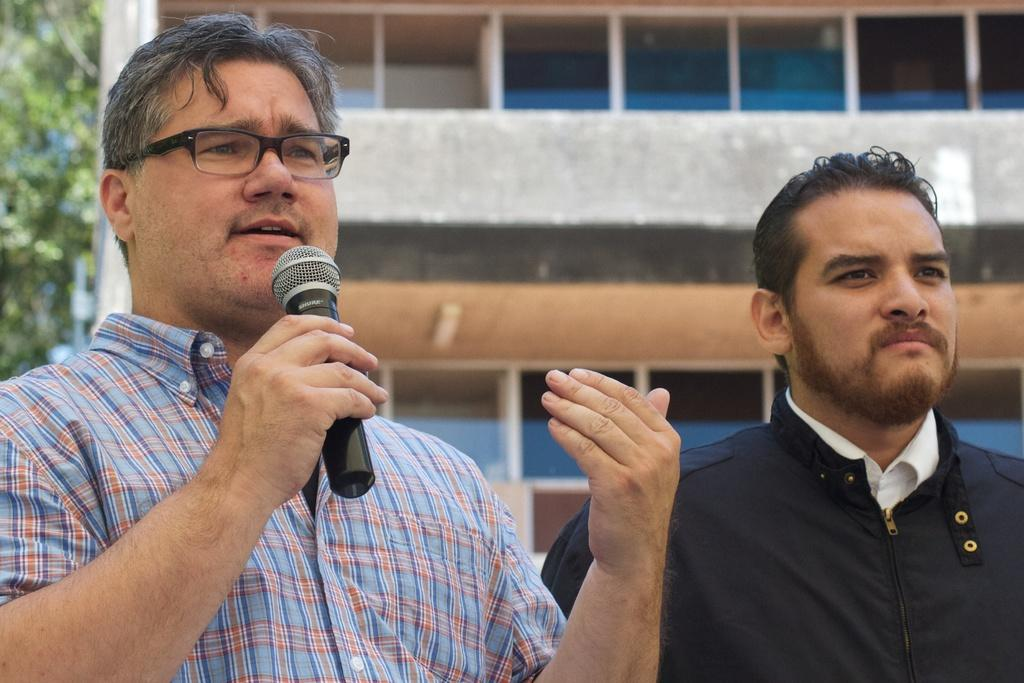How many people are in the image? There are two men standing in the image. What is the man on the left holding? The man on the left is holding a microphone. What can be seen in the background of the image? There is a building in the background of the image. What type of vegetation is visible to the left of the image? There are leaves of a tree visible to the left of the image. What type of spacecraft can be seen in the image? There is no spacecraft present in the image. Is there a tent visible in the image? There is no tent present in the image. 